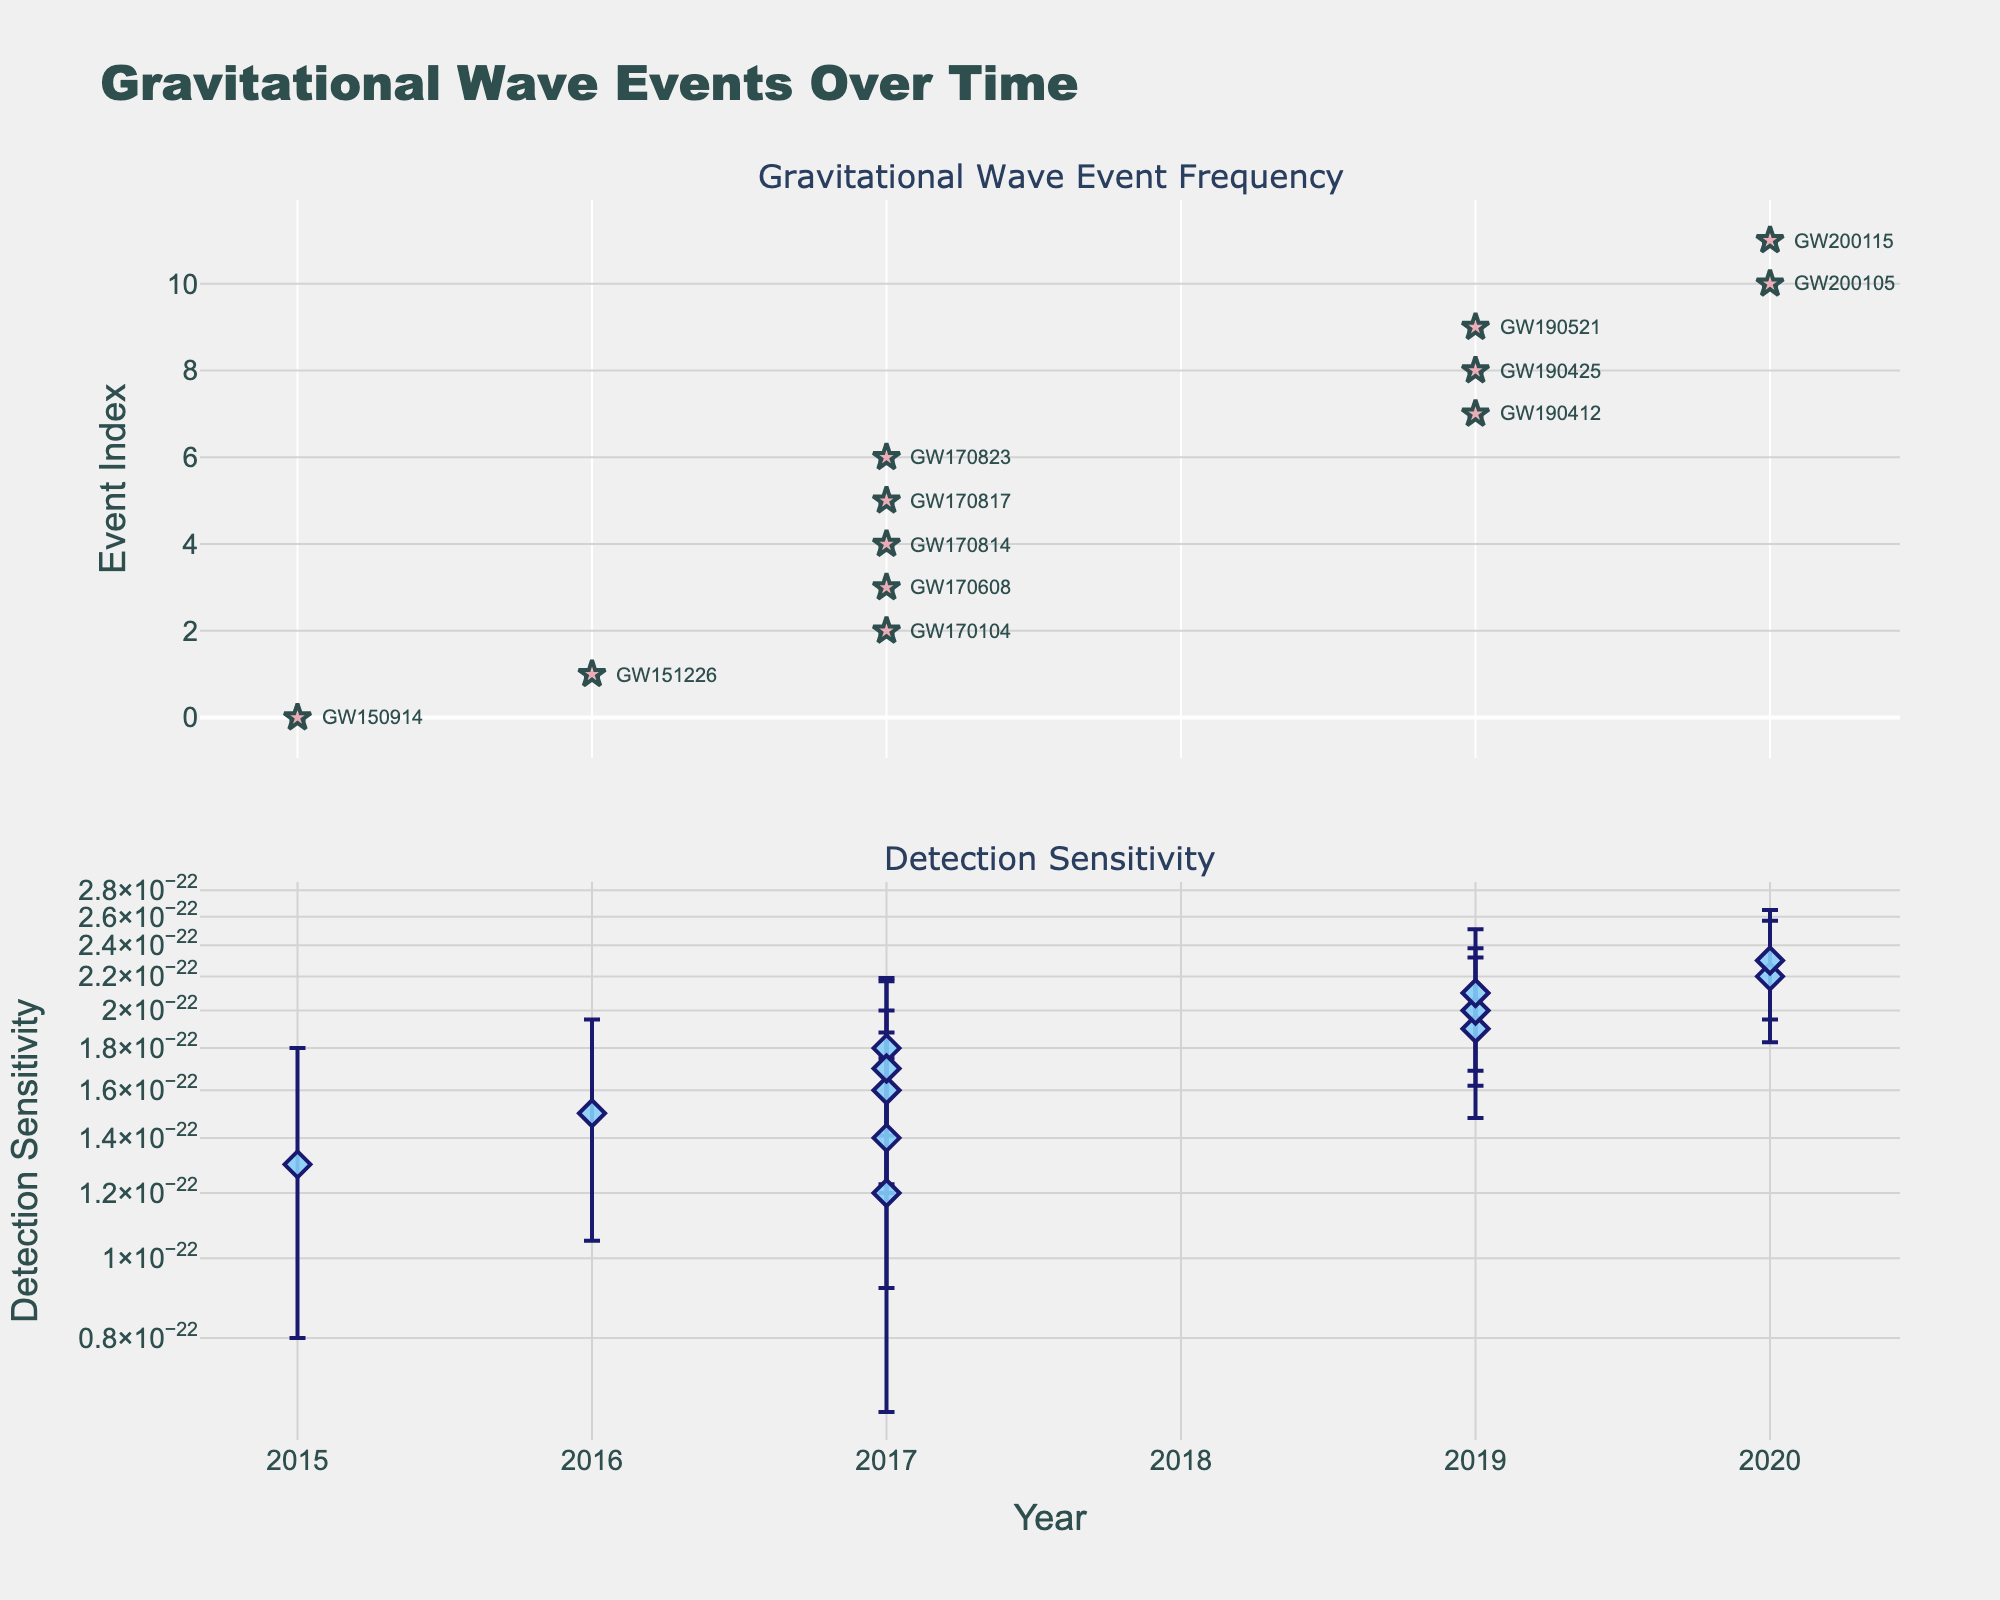What is the title of the figure? The title of the figure is written at the top and usually summarizing what the figure represents.
Answer: Gravitational Wave Events Over Time How is the "Event Frequency" visually represented on the figure? Event Frequency is represented by markers (stars) on a scatter plot in the upper subplot, with error bars indicating the uncertainty.
Answer: Star markers with error bars What year has the highest detection sensitivity? In the lower subplot, the detection sensitivity values increase over time. The highest value is at the rightmost end of the x-axis, which corresponds to the year 2020.
Answer: 2020 How many events were detected in 2017? The figure's annotations and markers on the x-axis in the top subplot show multiple events for 2017. Counting the annotated event names for 2017, there are six events.
Answer: Six Compare the detection sensitivity for the events GW190521 and GW200105. Which event has higher sensitivity? In the lower subplot, locate the markers for 2019 and 2020. Compare their y-values: GW190521 (2019) has a log-scaled detection sensitivity approximately at 2.1E-22, and GW200105 (2020) is around 2.2E-22.
Answer: GW200105 What trend do you observe in the detection sensitivity over time? Observing the lower subplot, detection sensitivity values generally increase as you move from left to right (from earlier to later years).
Answer: Increasing trend What is the error margin for the detection sensitivity of GW170817? Locate GW170817 in the lower subplot for 2017 and read the error bar length associated with it. It's given as 3.9E-23.
Answer: 3.9E-23 Which year has the most detected gravitational wave events? Count the markers in the top subplot for each year. The year with the most markers will have the most events. 2017 has the highest count with six events.
Answer: 2017 Did detection sensitivity become more precise over the years? Compare the size of the error bars in the lower subplot across different years. The error bars appear to decrease in size from 2015 to 2020, indicating increased precision.
Answer: Yes What is the relation between event frequency and detection sensitivity for any given year? For instance, 2016. For 2016, look at both subplots: locate the event frequency on the top subplot and the detection sensitivity on the bottom subplot. In 2016, the event frequency marked by GW151226 appears with associated sensitivity around 1.5E-22, suggesting that as new events are detected, detection sensitivity tends to increase.
Answer: Both are presented together in higher frequency years, with no direct math link 